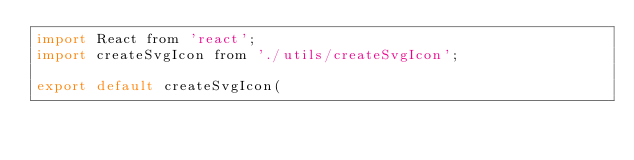Convert code to text. <code><loc_0><loc_0><loc_500><loc_500><_JavaScript_>import React from 'react';
import createSvgIcon from './utils/createSvgIcon';

export default createSvgIcon(</code> 